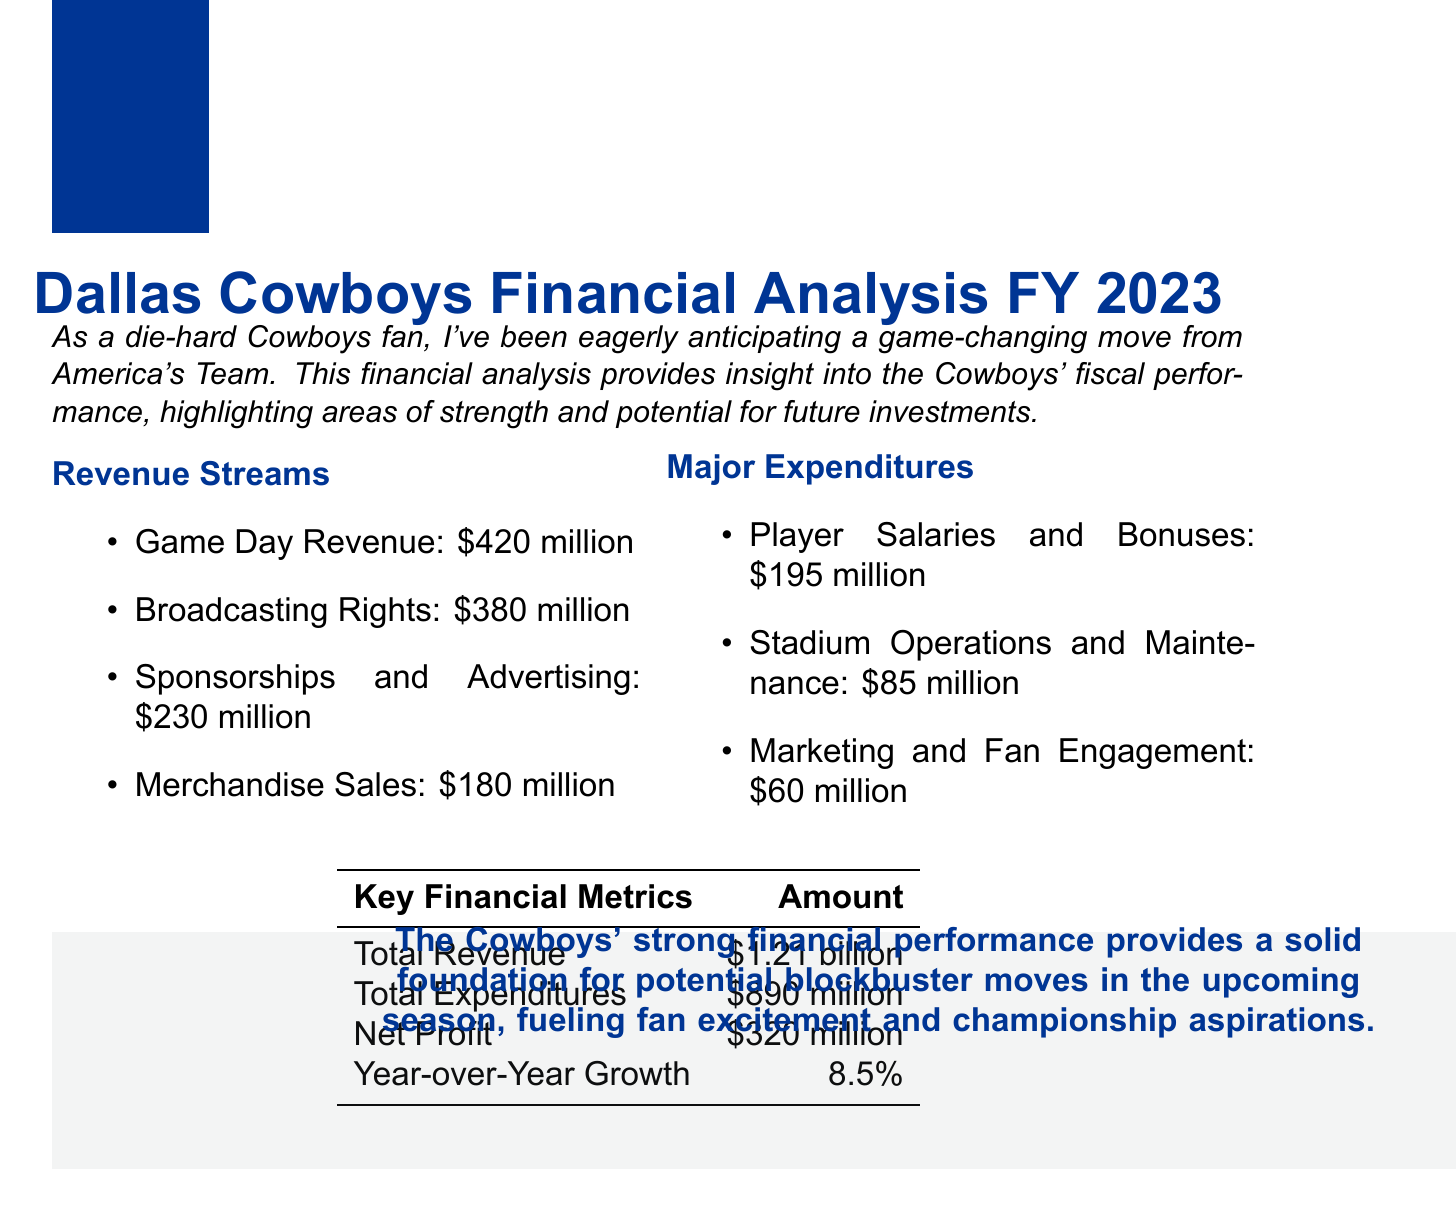What is the total revenue for FY 2023? The total revenue is reported as $1.21 billion, which reflects the Cowboys' total earnings from all streams.
Answer: $1.21 billion How much did the Cowboys earn from game day revenue? Game day revenue specifically mentioned refers to ticket sales, concessions, and parking, which amounts to $420 million.
Answer: $420 million What is the amount spent on player salaries and bonuses? The document specifies that player salaries and bonuses cost $195 million, including Dak Prescott's salary.
Answer: $195 million What is the year-over-year growth percentage? The year-over-year growth is noted as 8.5%, reflecting the increase in financial performance from the previous year.
Answer: 8.5% Which category of revenue has the highest amount? Game Day Revenue, which totals $420 million, is identified as the highest revenue stream among all categories listed.
Answer: Game Day Revenue What are the major expenditures for the Cowboys? Major expenditures listed include player salaries and bonuses, stadium operations, and marketing engagement, totaling $340 million combined.
Answer: $340 million What is the net profit for the fiscal year? The net profit, calculated as total revenue minus total expenditures, is reported as $320 million.
Answer: $320 million Who are some of the major sponsors for the team? The document lists AT&T, Ford, and Nike as major partners in sponsorship and advertising.
Answer: AT&T, Ford, Nike What is the amount allocated for marketing and fan engagement? The expenditure specifically for marketing and fan engagement is detailed as $60 million.
Answer: $60 million 